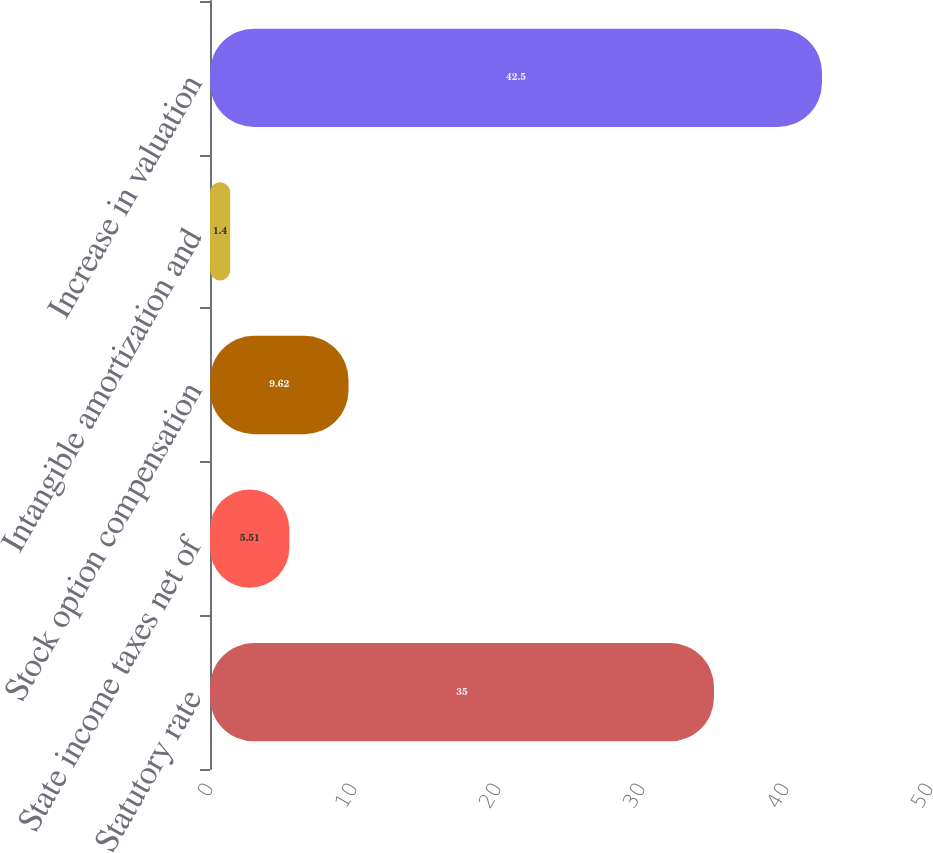<chart> <loc_0><loc_0><loc_500><loc_500><bar_chart><fcel>Statutory rate<fcel>State income taxes net of<fcel>Stock option compensation<fcel>Intangible amortization and<fcel>Increase in valuation<nl><fcel>35<fcel>5.51<fcel>9.62<fcel>1.4<fcel>42.5<nl></chart> 